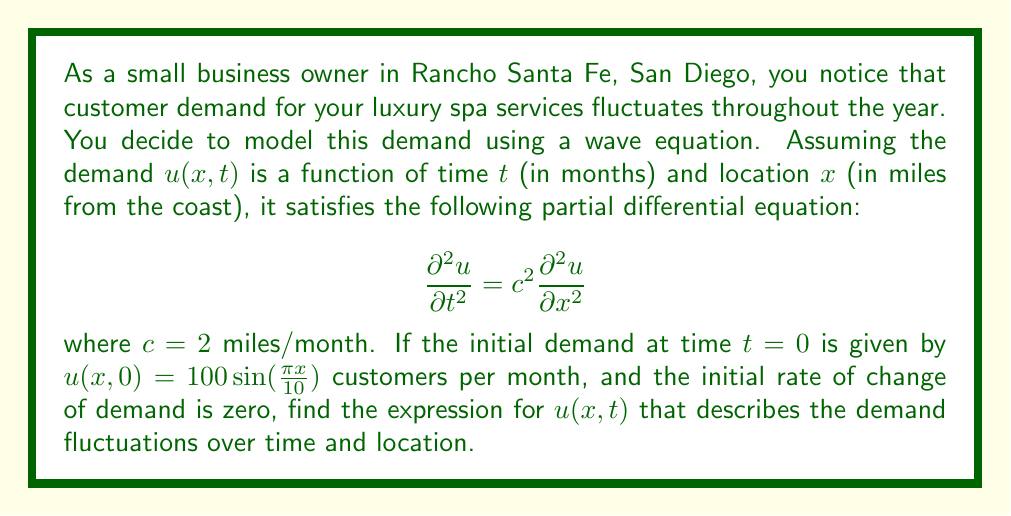Solve this math problem. To solve this wave equation, we'll follow these steps:

1) The general solution for a wave equation with initial conditions $u(x,0) = f(x)$ and $\frac{\partial u}{\partial t}(x,0) = g(x)$ is given by d'Alembert's formula:

   $$u(x,t) = \frac{1}{2}[f(x+ct) + f(x-ct)] + \frac{1}{2c}\int_{x-ct}^{x+ct} g(s) ds$$

2) In our case, $f(x) = 100 \sin(\frac{\pi x}{10})$ and $g(x) = 0$.

3) Substituting these into d'Alembert's formula:

   $$u(x,t) = \frac{1}{2}[100 \sin(\frac{\pi(x+ct)}{10}) + 100 \sin(\frac{\pi(x-ct)}{10})] + 0$$

4) Simplify:

   $$u(x,t) = 50 [\sin(\frac{\pi(x+ct)}{10}) + \sin(\frac{\pi(x-ct)}{10})]$$

5) Using the trigonometric identity $\sin A + \sin B = 2 \sin(\frac{A+B}{2}) \cos(\frac{A-B}{2})$:

   $$u(x,t) = 50 [2 \sin(\frac{\pi x}{10}) \cos(\frac{\pi ct}{10})]$$

6) Simplify further:

   $$u(x,t) = 100 \sin(\frac{\pi x}{10}) \cos(\frac{\pi ct}{10})$$

7) Remember that $c = 2$ miles/month, so our final expression is:

   $$u(x,t) = 100 \sin(\frac{\pi x}{10}) \cos(\frac{\pi t}{5})$$

This expression describes the demand fluctuations as a function of distance from the coast $(x)$ and time $(t)$.
Answer: $$u(x,t) = 100 \sin(\frac{\pi x}{10}) \cos(\frac{\pi t}{5})$$ 